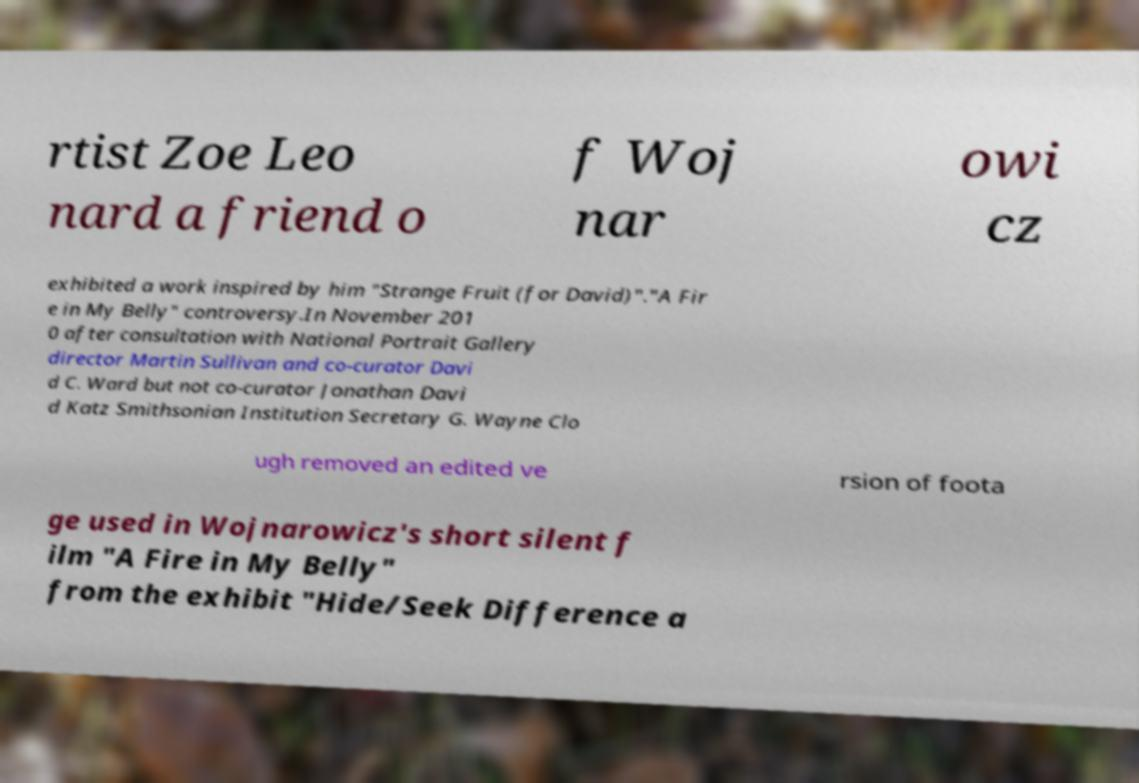I need the written content from this picture converted into text. Can you do that? rtist Zoe Leo nard a friend o f Woj nar owi cz exhibited a work inspired by him "Strange Fruit (for David)"."A Fir e in My Belly" controversy.In November 201 0 after consultation with National Portrait Gallery director Martin Sullivan and co-curator Davi d C. Ward but not co-curator Jonathan Davi d Katz Smithsonian Institution Secretary G. Wayne Clo ugh removed an edited ve rsion of foota ge used in Wojnarowicz's short silent f ilm "A Fire in My Belly" from the exhibit "Hide/Seek Difference a 